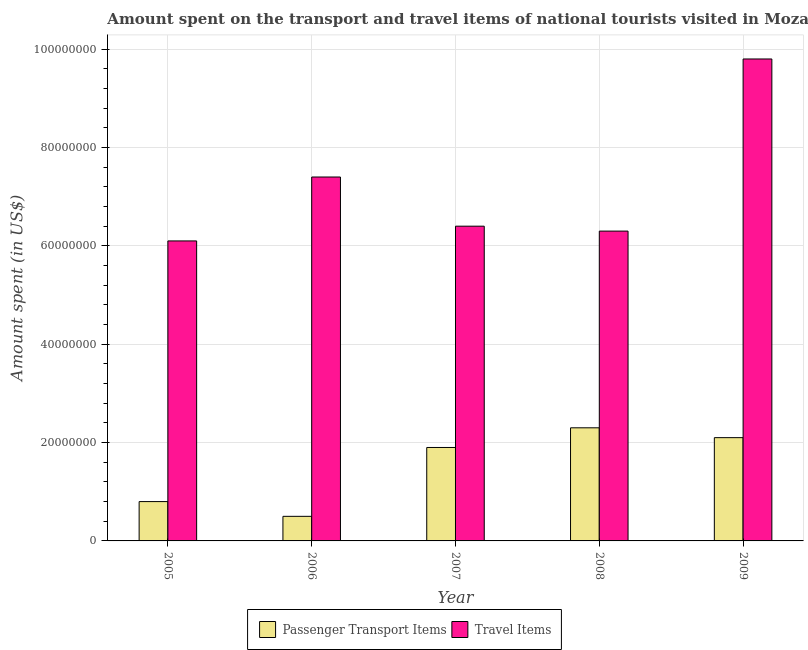How many different coloured bars are there?
Offer a terse response. 2. How many groups of bars are there?
Give a very brief answer. 5. How many bars are there on the 3rd tick from the left?
Your answer should be compact. 2. How many bars are there on the 1st tick from the right?
Give a very brief answer. 2. What is the label of the 2nd group of bars from the left?
Your response must be concise. 2006. In how many cases, is the number of bars for a given year not equal to the number of legend labels?
Ensure brevity in your answer.  0. What is the amount spent on passenger transport items in 2005?
Your response must be concise. 8.00e+06. Across all years, what is the maximum amount spent in travel items?
Provide a short and direct response. 9.80e+07. Across all years, what is the minimum amount spent on passenger transport items?
Provide a succinct answer. 5.00e+06. What is the total amount spent in travel items in the graph?
Your response must be concise. 3.60e+08. What is the difference between the amount spent in travel items in 2007 and that in 2009?
Your answer should be compact. -3.40e+07. What is the difference between the amount spent on passenger transport items in 2007 and the amount spent in travel items in 2009?
Your answer should be compact. -2.00e+06. What is the average amount spent on passenger transport items per year?
Your response must be concise. 1.52e+07. In how many years, is the amount spent on passenger transport items greater than 44000000 US$?
Your answer should be compact. 0. What is the ratio of the amount spent in travel items in 2005 to that in 2009?
Give a very brief answer. 0.62. Is the difference between the amount spent in travel items in 2007 and 2008 greater than the difference between the amount spent on passenger transport items in 2007 and 2008?
Your answer should be very brief. No. What is the difference between the highest and the second highest amount spent on passenger transport items?
Offer a very short reply. 2.00e+06. What is the difference between the highest and the lowest amount spent in travel items?
Provide a succinct answer. 3.70e+07. Is the sum of the amount spent on passenger transport items in 2008 and 2009 greater than the maximum amount spent in travel items across all years?
Give a very brief answer. Yes. What does the 2nd bar from the left in 2007 represents?
Provide a short and direct response. Travel Items. What does the 1st bar from the right in 2005 represents?
Make the answer very short. Travel Items. How many bars are there?
Give a very brief answer. 10. Are the values on the major ticks of Y-axis written in scientific E-notation?
Your answer should be very brief. No. Does the graph contain any zero values?
Give a very brief answer. No. Does the graph contain grids?
Give a very brief answer. Yes. How are the legend labels stacked?
Your response must be concise. Horizontal. What is the title of the graph?
Your answer should be compact. Amount spent on the transport and travel items of national tourists visited in Mozambique. What is the label or title of the X-axis?
Offer a terse response. Year. What is the label or title of the Y-axis?
Offer a terse response. Amount spent (in US$). What is the Amount spent (in US$) of Travel Items in 2005?
Offer a very short reply. 6.10e+07. What is the Amount spent (in US$) in Travel Items in 2006?
Your answer should be very brief. 7.40e+07. What is the Amount spent (in US$) of Passenger Transport Items in 2007?
Your answer should be very brief. 1.90e+07. What is the Amount spent (in US$) in Travel Items in 2007?
Your answer should be very brief. 6.40e+07. What is the Amount spent (in US$) in Passenger Transport Items in 2008?
Provide a succinct answer. 2.30e+07. What is the Amount spent (in US$) of Travel Items in 2008?
Your answer should be very brief. 6.30e+07. What is the Amount spent (in US$) of Passenger Transport Items in 2009?
Offer a terse response. 2.10e+07. What is the Amount spent (in US$) of Travel Items in 2009?
Your answer should be very brief. 9.80e+07. Across all years, what is the maximum Amount spent (in US$) of Passenger Transport Items?
Provide a succinct answer. 2.30e+07. Across all years, what is the maximum Amount spent (in US$) in Travel Items?
Keep it short and to the point. 9.80e+07. Across all years, what is the minimum Amount spent (in US$) of Travel Items?
Offer a terse response. 6.10e+07. What is the total Amount spent (in US$) in Passenger Transport Items in the graph?
Give a very brief answer. 7.60e+07. What is the total Amount spent (in US$) in Travel Items in the graph?
Offer a very short reply. 3.60e+08. What is the difference between the Amount spent (in US$) of Travel Items in 2005 and that in 2006?
Your answer should be compact. -1.30e+07. What is the difference between the Amount spent (in US$) of Passenger Transport Items in 2005 and that in 2007?
Give a very brief answer. -1.10e+07. What is the difference between the Amount spent (in US$) of Travel Items in 2005 and that in 2007?
Provide a succinct answer. -3.00e+06. What is the difference between the Amount spent (in US$) of Passenger Transport Items in 2005 and that in 2008?
Provide a short and direct response. -1.50e+07. What is the difference between the Amount spent (in US$) in Travel Items in 2005 and that in 2008?
Provide a short and direct response. -2.00e+06. What is the difference between the Amount spent (in US$) of Passenger Transport Items in 2005 and that in 2009?
Your answer should be very brief. -1.30e+07. What is the difference between the Amount spent (in US$) of Travel Items in 2005 and that in 2009?
Offer a very short reply. -3.70e+07. What is the difference between the Amount spent (in US$) of Passenger Transport Items in 2006 and that in 2007?
Your answer should be compact. -1.40e+07. What is the difference between the Amount spent (in US$) of Passenger Transport Items in 2006 and that in 2008?
Your response must be concise. -1.80e+07. What is the difference between the Amount spent (in US$) of Travel Items in 2006 and that in 2008?
Your answer should be very brief. 1.10e+07. What is the difference between the Amount spent (in US$) of Passenger Transport Items in 2006 and that in 2009?
Give a very brief answer. -1.60e+07. What is the difference between the Amount spent (in US$) in Travel Items in 2006 and that in 2009?
Keep it short and to the point. -2.40e+07. What is the difference between the Amount spent (in US$) of Passenger Transport Items in 2007 and that in 2008?
Give a very brief answer. -4.00e+06. What is the difference between the Amount spent (in US$) of Travel Items in 2007 and that in 2008?
Give a very brief answer. 1.00e+06. What is the difference between the Amount spent (in US$) in Passenger Transport Items in 2007 and that in 2009?
Provide a short and direct response. -2.00e+06. What is the difference between the Amount spent (in US$) in Travel Items in 2007 and that in 2009?
Give a very brief answer. -3.40e+07. What is the difference between the Amount spent (in US$) of Travel Items in 2008 and that in 2009?
Give a very brief answer. -3.50e+07. What is the difference between the Amount spent (in US$) of Passenger Transport Items in 2005 and the Amount spent (in US$) of Travel Items in 2006?
Give a very brief answer. -6.60e+07. What is the difference between the Amount spent (in US$) of Passenger Transport Items in 2005 and the Amount spent (in US$) of Travel Items in 2007?
Keep it short and to the point. -5.60e+07. What is the difference between the Amount spent (in US$) in Passenger Transport Items in 2005 and the Amount spent (in US$) in Travel Items in 2008?
Give a very brief answer. -5.50e+07. What is the difference between the Amount spent (in US$) in Passenger Transport Items in 2005 and the Amount spent (in US$) in Travel Items in 2009?
Your answer should be compact. -9.00e+07. What is the difference between the Amount spent (in US$) of Passenger Transport Items in 2006 and the Amount spent (in US$) of Travel Items in 2007?
Provide a short and direct response. -5.90e+07. What is the difference between the Amount spent (in US$) in Passenger Transport Items in 2006 and the Amount spent (in US$) in Travel Items in 2008?
Offer a terse response. -5.80e+07. What is the difference between the Amount spent (in US$) in Passenger Transport Items in 2006 and the Amount spent (in US$) in Travel Items in 2009?
Give a very brief answer. -9.30e+07. What is the difference between the Amount spent (in US$) of Passenger Transport Items in 2007 and the Amount spent (in US$) of Travel Items in 2008?
Your response must be concise. -4.40e+07. What is the difference between the Amount spent (in US$) of Passenger Transport Items in 2007 and the Amount spent (in US$) of Travel Items in 2009?
Give a very brief answer. -7.90e+07. What is the difference between the Amount spent (in US$) of Passenger Transport Items in 2008 and the Amount spent (in US$) of Travel Items in 2009?
Keep it short and to the point. -7.50e+07. What is the average Amount spent (in US$) in Passenger Transport Items per year?
Offer a very short reply. 1.52e+07. What is the average Amount spent (in US$) of Travel Items per year?
Give a very brief answer. 7.20e+07. In the year 2005, what is the difference between the Amount spent (in US$) in Passenger Transport Items and Amount spent (in US$) in Travel Items?
Give a very brief answer. -5.30e+07. In the year 2006, what is the difference between the Amount spent (in US$) in Passenger Transport Items and Amount spent (in US$) in Travel Items?
Offer a terse response. -6.90e+07. In the year 2007, what is the difference between the Amount spent (in US$) of Passenger Transport Items and Amount spent (in US$) of Travel Items?
Your answer should be very brief. -4.50e+07. In the year 2008, what is the difference between the Amount spent (in US$) in Passenger Transport Items and Amount spent (in US$) in Travel Items?
Keep it short and to the point. -4.00e+07. In the year 2009, what is the difference between the Amount spent (in US$) of Passenger Transport Items and Amount spent (in US$) of Travel Items?
Give a very brief answer. -7.70e+07. What is the ratio of the Amount spent (in US$) of Passenger Transport Items in 2005 to that in 2006?
Your answer should be compact. 1.6. What is the ratio of the Amount spent (in US$) in Travel Items in 2005 to that in 2006?
Provide a short and direct response. 0.82. What is the ratio of the Amount spent (in US$) of Passenger Transport Items in 2005 to that in 2007?
Make the answer very short. 0.42. What is the ratio of the Amount spent (in US$) of Travel Items in 2005 to that in 2007?
Offer a very short reply. 0.95. What is the ratio of the Amount spent (in US$) of Passenger Transport Items in 2005 to that in 2008?
Make the answer very short. 0.35. What is the ratio of the Amount spent (in US$) in Travel Items in 2005 to that in 2008?
Offer a terse response. 0.97. What is the ratio of the Amount spent (in US$) of Passenger Transport Items in 2005 to that in 2009?
Your answer should be very brief. 0.38. What is the ratio of the Amount spent (in US$) of Travel Items in 2005 to that in 2009?
Provide a short and direct response. 0.62. What is the ratio of the Amount spent (in US$) of Passenger Transport Items in 2006 to that in 2007?
Offer a very short reply. 0.26. What is the ratio of the Amount spent (in US$) in Travel Items in 2006 to that in 2007?
Offer a terse response. 1.16. What is the ratio of the Amount spent (in US$) in Passenger Transport Items in 2006 to that in 2008?
Your answer should be very brief. 0.22. What is the ratio of the Amount spent (in US$) in Travel Items in 2006 to that in 2008?
Offer a very short reply. 1.17. What is the ratio of the Amount spent (in US$) of Passenger Transport Items in 2006 to that in 2009?
Make the answer very short. 0.24. What is the ratio of the Amount spent (in US$) of Travel Items in 2006 to that in 2009?
Provide a short and direct response. 0.76. What is the ratio of the Amount spent (in US$) in Passenger Transport Items in 2007 to that in 2008?
Provide a short and direct response. 0.83. What is the ratio of the Amount spent (in US$) in Travel Items in 2007 to that in 2008?
Your response must be concise. 1.02. What is the ratio of the Amount spent (in US$) in Passenger Transport Items in 2007 to that in 2009?
Offer a very short reply. 0.9. What is the ratio of the Amount spent (in US$) in Travel Items in 2007 to that in 2009?
Give a very brief answer. 0.65. What is the ratio of the Amount spent (in US$) of Passenger Transport Items in 2008 to that in 2009?
Make the answer very short. 1.1. What is the ratio of the Amount spent (in US$) in Travel Items in 2008 to that in 2009?
Provide a succinct answer. 0.64. What is the difference between the highest and the second highest Amount spent (in US$) in Travel Items?
Your answer should be very brief. 2.40e+07. What is the difference between the highest and the lowest Amount spent (in US$) of Passenger Transport Items?
Your response must be concise. 1.80e+07. What is the difference between the highest and the lowest Amount spent (in US$) in Travel Items?
Give a very brief answer. 3.70e+07. 